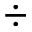<formula> <loc_0><loc_0><loc_500><loc_500>\div</formula> 